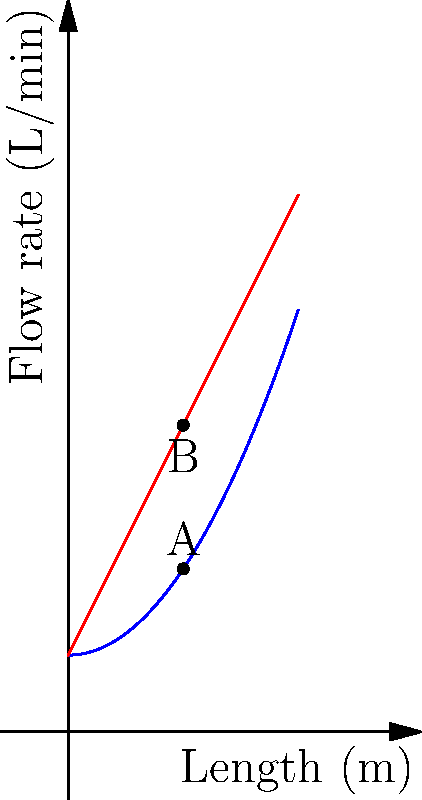In a whisky distillery, two types of still condensers are being compared: a curved condenser (blue) and a straight condenser (red). The flow rate (in L/min) of whisky through each condenser is represented as a function of length (in meters). At a length of 1.5 meters, what is the difference in flow rate between the curved and straight condensers? Express your answer in terms of L/min, rounded to two decimal places. To solve this problem, we need to follow these steps:

1. Identify the functions representing each condenser:
   - Curved condenser (blue): $f(x) = 0.5x^2 + 1$
   - Straight condenser (red): $g(x) = 2x + 1$

2. Calculate the flow rate for each condenser at x = 1.5 m:
   - For the curved condenser:
     $f(1.5) = 0.5(1.5)^2 + 1 = 0.5(2.25) + 1 = 1.125 + 1 = 2.125$ L/min

   - For the straight condenser:
     $g(1.5) = 2(1.5) + 1 = 3 + 1 = 4$ L/min

3. Calculate the difference in flow rate:
   Difference = Straight condenser - Curved condenser
   $= g(1.5) - f(1.5) = 4 - 2.125 = 1.875$ L/min

4. Round the result to two decimal places:
   1.875 ≈ 1.88 L/min

Therefore, the difference in flow rate between the straight and curved condensers at a length of 1.5 meters is 1.88 L/min.
Answer: 1.88 L/min 